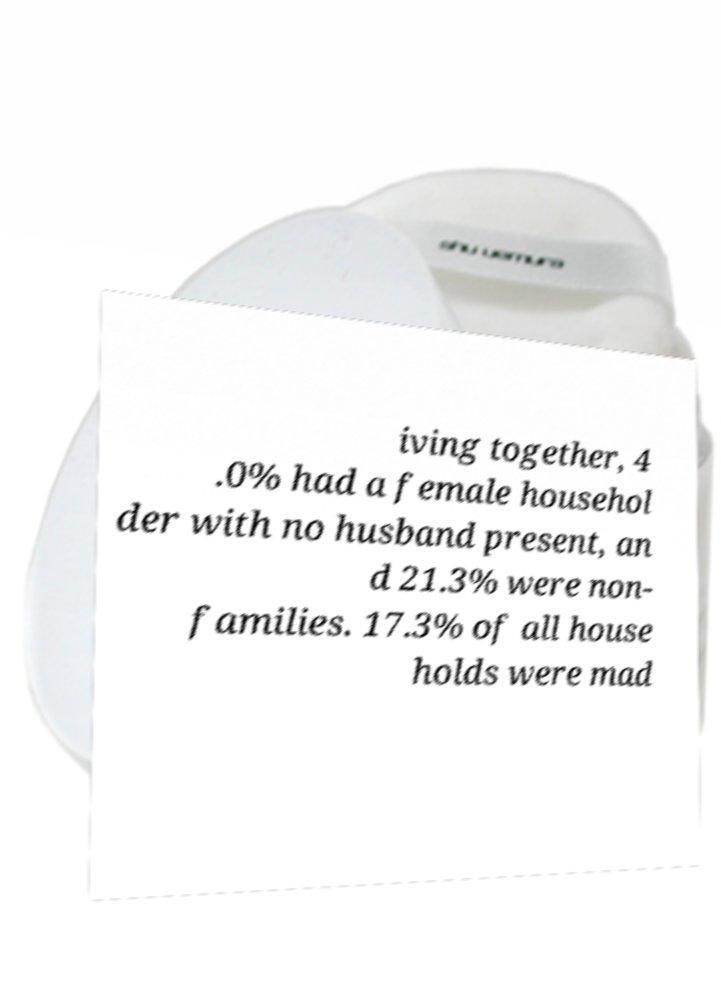Please read and relay the text visible in this image. What does it say? iving together, 4 .0% had a female househol der with no husband present, an d 21.3% were non- families. 17.3% of all house holds were mad 